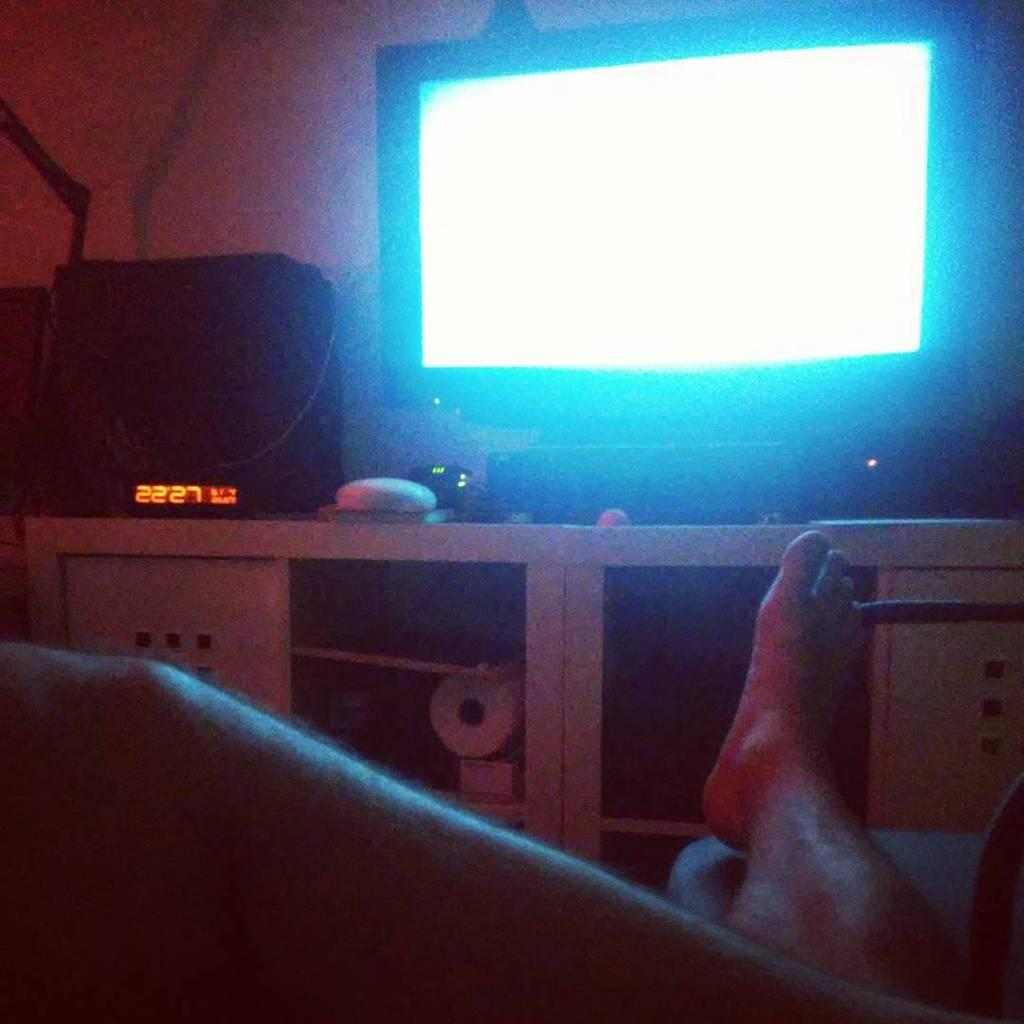<image>
Create a compact narrative representing the image presented. A person sitting in front of a television at 22:27 p.m. 